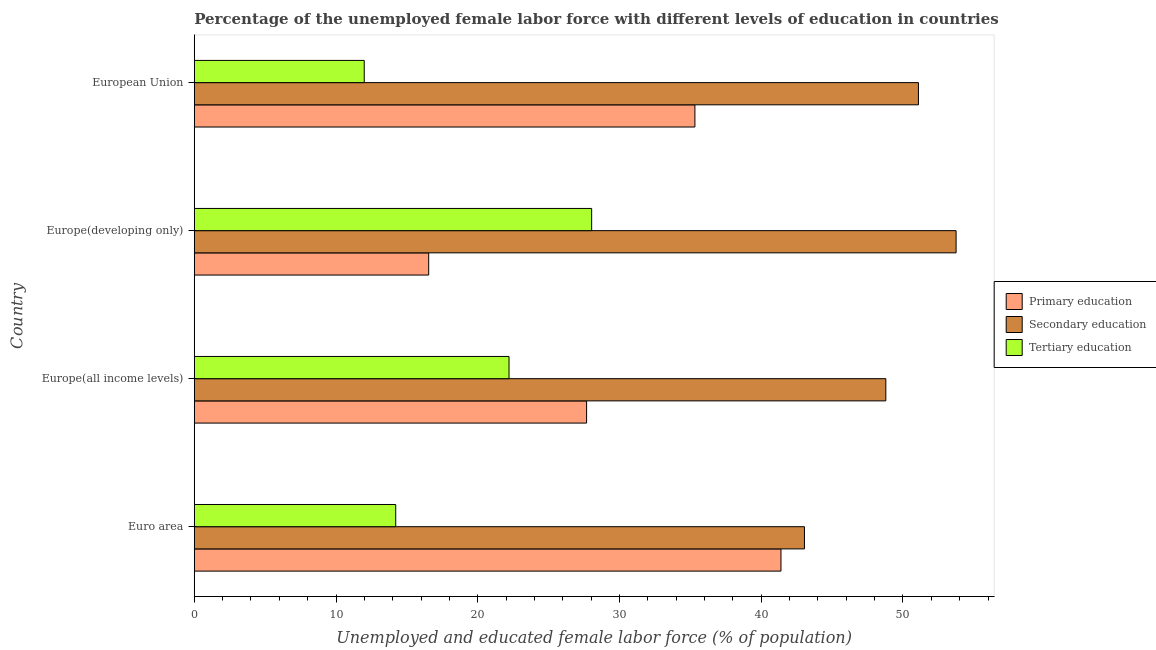How many different coloured bars are there?
Offer a very short reply. 3. Are the number of bars per tick equal to the number of legend labels?
Offer a terse response. Yes. Are the number of bars on each tick of the Y-axis equal?
Ensure brevity in your answer.  Yes. What is the label of the 1st group of bars from the top?
Keep it short and to the point. European Union. In how many cases, is the number of bars for a given country not equal to the number of legend labels?
Make the answer very short. 0. What is the percentage of female labor force who received secondary education in Euro area?
Your answer should be very brief. 43.05. Across all countries, what is the maximum percentage of female labor force who received tertiary education?
Offer a terse response. 28.04. Across all countries, what is the minimum percentage of female labor force who received tertiary education?
Provide a short and direct response. 11.99. In which country was the percentage of female labor force who received primary education maximum?
Your answer should be very brief. Euro area. What is the total percentage of female labor force who received primary education in the graph?
Provide a short and direct response. 120.93. What is the difference between the percentage of female labor force who received primary education in Euro area and that in Europe(all income levels)?
Provide a short and direct response. 13.71. What is the difference between the percentage of female labor force who received primary education in Europe(developing only) and the percentage of female labor force who received tertiary education in Europe(all income levels)?
Ensure brevity in your answer.  -5.67. What is the average percentage of female labor force who received secondary education per country?
Ensure brevity in your answer.  49.17. What is the difference between the percentage of female labor force who received primary education and percentage of female labor force who received tertiary education in European Union?
Provide a short and direct response. 23.33. In how many countries, is the percentage of female labor force who received secondary education greater than 50 %?
Your answer should be compact. 2. What is the ratio of the percentage of female labor force who received primary education in Europe(developing only) to that in European Union?
Make the answer very short. 0.47. Is the percentage of female labor force who received primary education in Europe(all income levels) less than that in Europe(developing only)?
Keep it short and to the point. No. What is the difference between the highest and the second highest percentage of female labor force who received secondary education?
Keep it short and to the point. 2.66. What is the difference between the highest and the lowest percentage of female labor force who received secondary education?
Offer a terse response. 10.7. In how many countries, is the percentage of female labor force who received tertiary education greater than the average percentage of female labor force who received tertiary education taken over all countries?
Your answer should be very brief. 2. What does the 2nd bar from the top in European Union represents?
Provide a succinct answer. Secondary education. What does the 1st bar from the bottom in Europe(developing only) represents?
Ensure brevity in your answer.  Primary education. Is it the case that in every country, the sum of the percentage of female labor force who received primary education and percentage of female labor force who received secondary education is greater than the percentage of female labor force who received tertiary education?
Give a very brief answer. Yes. How many countries are there in the graph?
Provide a succinct answer. 4. Are the values on the major ticks of X-axis written in scientific E-notation?
Provide a short and direct response. No. How many legend labels are there?
Your answer should be very brief. 3. What is the title of the graph?
Provide a short and direct response. Percentage of the unemployed female labor force with different levels of education in countries. What is the label or title of the X-axis?
Keep it short and to the point. Unemployed and educated female labor force (% of population). What is the label or title of the Y-axis?
Your answer should be compact. Country. What is the Unemployed and educated female labor force (% of population) of Primary education in Euro area?
Offer a very short reply. 41.39. What is the Unemployed and educated female labor force (% of population) in Secondary education in Euro area?
Ensure brevity in your answer.  43.05. What is the Unemployed and educated female labor force (% of population) of Tertiary education in Euro area?
Keep it short and to the point. 14.21. What is the Unemployed and educated female labor force (% of population) in Primary education in Europe(all income levels)?
Offer a terse response. 27.68. What is the Unemployed and educated female labor force (% of population) of Secondary education in Europe(all income levels)?
Offer a very short reply. 48.79. What is the Unemployed and educated female labor force (% of population) of Tertiary education in Europe(all income levels)?
Offer a very short reply. 22.21. What is the Unemployed and educated female labor force (% of population) of Primary education in Europe(developing only)?
Ensure brevity in your answer.  16.54. What is the Unemployed and educated female labor force (% of population) in Secondary education in Europe(developing only)?
Make the answer very short. 53.75. What is the Unemployed and educated female labor force (% of population) of Tertiary education in Europe(developing only)?
Provide a short and direct response. 28.04. What is the Unemployed and educated female labor force (% of population) in Primary education in European Union?
Offer a very short reply. 35.32. What is the Unemployed and educated female labor force (% of population) of Secondary education in European Union?
Your answer should be compact. 51.09. What is the Unemployed and educated female labor force (% of population) in Tertiary education in European Union?
Offer a terse response. 11.99. Across all countries, what is the maximum Unemployed and educated female labor force (% of population) in Primary education?
Offer a terse response. 41.39. Across all countries, what is the maximum Unemployed and educated female labor force (% of population) of Secondary education?
Make the answer very short. 53.75. Across all countries, what is the maximum Unemployed and educated female labor force (% of population) in Tertiary education?
Offer a very short reply. 28.04. Across all countries, what is the minimum Unemployed and educated female labor force (% of population) in Primary education?
Keep it short and to the point. 16.54. Across all countries, what is the minimum Unemployed and educated female labor force (% of population) of Secondary education?
Make the answer very short. 43.05. Across all countries, what is the minimum Unemployed and educated female labor force (% of population) in Tertiary education?
Your response must be concise. 11.99. What is the total Unemployed and educated female labor force (% of population) of Primary education in the graph?
Your answer should be compact. 120.93. What is the total Unemployed and educated female labor force (% of population) in Secondary education in the graph?
Your answer should be very brief. 196.68. What is the total Unemployed and educated female labor force (% of population) of Tertiary education in the graph?
Your answer should be very brief. 76.45. What is the difference between the Unemployed and educated female labor force (% of population) in Primary education in Euro area and that in Europe(all income levels)?
Give a very brief answer. 13.71. What is the difference between the Unemployed and educated female labor force (% of population) of Secondary education in Euro area and that in Europe(all income levels)?
Your answer should be very brief. -5.74. What is the difference between the Unemployed and educated female labor force (% of population) in Tertiary education in Euro area and that in Europe(all income levels)?
Keep it short and to the point. -7.99. What is the difference between the Unemployed and educated female labor force (% of population) of Primary education in Euro area and that in Europe(developing only)?
Provide a succinct answer. 24.85. What is the difference between the Unemployed and educated female labor force (% of population) of Secondary education in Euro area and that in Europe(developing only)?
Keep it short and to the point. -10.7. What is the difference between the Unemployed and educated female labor force (% of population) in Tertiary education in Euro area and that in Europe(developing only)?
Keep it short and to the point. -13.82. What is the difference between the Unemployed and educated female labor force (% of population) in Primary education in Euro area and that in European Union?
Provide a short and direct response. 6.07. What is the difference between the Unemployed and educated female labor force (% of population) of Secondary education in Euro area and that in European Union?
Provide a short and direct response. -8.04. What is the difference between the Unemployed and educated female labor force (% of population) of Tertiary education in Euro area and that in European Union?
Ensure brevity in your answer.  2.22. What is the difference between the Unemployed and educated female labor force (% of population) in Primary education in Europe(all income levels) and that in Europe(developing only)?
Provide a short and direct response. 11.14. What is the difference between the Unemployed and educated female labor force (% of population) of Secondary education in Europe(all income levels) and that in Europe(developing only)?
Ensure brevity in your answer.  -4.96. What is the difference between the Unemployed and educated female labor force (% of population) in Tertiary education in Europe(all income levels) and that in Europe(developing only)?
Your response must be concise. -5.83. What is the difference between the Unemployed and educated female labor force (% of population) of Primary education in Europe(all income levels) and that in European Union?
Give a very brief answer. -7.64. What is the difference between the Unemployed and educated female labor force (% of population) in Secondary education in Europe(all income levels) and that in European Union?
Keep it short and to the point. -2.3. What is the difference between the Unemployed and educated female labor force (% of population) of Tertiary education in Europe(all income levels) and that in European Union?
Ensure brevity in your answer.  10.21. What is the difference between the Unemployed and educated female labor force (% of population) in Primary education in Europe(developing only) and that in European Union?
Your response must be concise. -18.78. What is the difference between the Unemployed and educated female labor force (% of population) of Secondary education in Europe(developing only) and that in European Union?
Ensure brevity in your answer.  2.66. What is the difference between the Unemployed and educated female labor force (% of population) in Tertiary education in Europe(developing only) and that in European Union?
Provide a short and direct response. 16.04. What is the difference between the Unemployed and educated female labor force (% of population) in Primary education in Euro area and the Unemployed and educated female labor force (% of population) in Secondary education in Europe(all income levels)?
Your answer should be very brief. -7.4. What is the difference between the Unemployed and educated female labor force (% of population) in Primary education in Euro area and the Unemployed and educated female labor force (% of population) in Tertiary education in Europe(all income levels)?
Ensure brevity in your answer.  19.19. What is the difference between the Unemployed and educated female labor force (% of population) of Secondary education in Euro area and the Unemployed and educated female labor force (% of population) of Tertiary education in Europe(all income levels)?
Give a very brief answer. 20.84. What is the difference between the Unemployed and educated female labor force (% of population) in Primary education in Euro area and the Unemployed and educated female labor force (% of population) in Secondary education in Europe(developing only)?
Ensure brevity in your answer.  -12.35. What is the difference between the Unemployed and educated female labor force (% of population) of Primary education in Euro area and the Unemployed and educated female labor force (% of population) of Tertiary education in Europe(developing only)?
Make the answer very short. 13.36. What is the difference between the Unemployed and educated female labor force (% of population) in Secondary education in Euro area and the Unemployed and educated female labor force (% of population) in Tertiary education in Europe(developing only)?
Give a very brief answer. 15.01. What is the difference between the Unemployed and educated female labor force (% of population) of Primary education in Euro area and the Unemployed and educated female labor force (% of population) of Secondary education in European Union?
Offer a terse response. -9.7. What is the difference between the Unemployed and educated female labor force (% of population) of Primary education in Euro area and the Unemployed and educated female labor force (% of population) of Tertiary education in European Union?
Your answer should be compact. 29.4. What is the difference between the Unemployed and educated female labor force (% of population) of Secondary education in Euro area and the Unemployed and educated female labor force (% of population) of Tertiary education in European Union?
Offer a very short reply. 31.06. What is the difference between the Unemployed and educated female labor force (% of population) in Primary education in Europe(all income levels) and the Unemployed and educated female labor force (% of population) in Secondary education in Europe(developing only)?
Keep it short and to the point. -26.07. What is the difference between the Unemployed and educated female labor force (% of population) of Primary education in Europe(all income levels) and the Unemployed and educated female labor force (% of population) of Tertiary education in Europe(developing only)?
Your answer should be compact. -0.36. What is the difference between the Unemployed and educated female labor force (% of population) of Secondary education in Europe(all income levels) and the Unemployed and educated female labor force (% of population) of Tertiary education in Europe(developing only)?
Your answer should be very brief. 20.76. What is the difference between the Unemployed and educated female labor force (% of population) in Primary education in Europe(all income levels) and the Unemployed and educated female labor force (% of population) in Secondary education in European Union?
Provide a short and direct response. -23.41. What is the difference between the Unemployed and educated female labor force (% of population) in Primary education in Europe(all income levels) and the Unemployed and educated female labor force (% of population) in Tertiary education in European Union?
Ensure brevity in your answer.  15.69. What is the difference between the Unemployed and educated female labor force (% of population) in Secondary education in Europe(all income levels) and the Unemployed and educated female labor force (% of population) in Tertiary education in European Union?
Give a very brief answer. 36.8. What is the difference between the Unemployed and educated female labor force (% of population) of Primary education in Europe(developing only) and the Unemployed and educated female labor force (% of population) of Secondary education in European Union?
Offer a terse response. -34.55. What is the difference between the Unemployed and educated female labor force (% of population) in Primary education in Europe(developing only) and the Unemployed and educated female labor force (% of population) in Tertiary education in European Union?
Ensure brevity in your answer.  4.55. What is the difference between the Unemployed and educated female labor force (% of population) in Secondary education in Europe(developing only) and the Unemployed and educated female labor force (% of population) in Tertiary education in European Union?
Your response must be concise. 41.76. What is the average Unemployed and educated female labor force (% of population) in Primary education per country?
Offer a very short reply. 30.23. What is the average Unemployed and educated female labor force (% of population) in Secondary education per country?
Your answer should be compact. 49.17. What is the average Unemployed and educated female labor force (% of population) in Tertiary education per country?
Provide a short and direct response. 19.11. What is the difference between the Unemployed and educated female labor force (% of population) in Primary education and Unemployed and educated female labor force (% of population) in Secondary education in Euro area?
Keep it short and to the point. -1.66. What is the difference between the Unemployed and educated female labor force (% of population) in Primary education and Unemployed and educated female labor force (% of population) in Tertiary education in Euro area?
Keep it short and to the point. 27.18. What is the difference between the Unemployed and educated female labor force (% of population) in Secondary education and Unemployed and educated female labor force (% of population) in Tertiary education in Euro area?
Your answer should be very brief. 28.84. What is the difference between the Unemployed and educated female labor force (% of population) of Primary education and Unemployed and educated female labor force (% of population) of Secondary education in Europe(all income levels)?
Keep it short and to the point. -21.11. What is the difference between the Unemployed and educated female labor force (% of population) of Primary education and Unemployed and educated female labor force (% of population) of Tertiary education in Europe(all income levels)?
Ensure brevity in your answer.  5.47. What is the difference between the Unemployed and educated female labor force (% of population) of Secondary education and Unemployed and educated female labor force (% of population) of Tertiary education in Europe(all income levels)?
Keep it short and to the point. 26.59. What is the difference between the Unemployed and educated female labor force (% of population) in Primary education and Unemployed and educated female labor force (% of population) in Secondary education in Europe(developing only)?
Make the answer very short. -37.21. What is the difference between the Unemployed and educated female labor force (% of population) in Primary education and Unemployed and educated female labor force (% of population) in Tertiary education in Europe(developing only)?
Your response must be concise. -11.5. What is the difference between the Unemployed and educated female labor force (% of population) of Secondary education and Unemployed and educated female labor force (% of population) of Tertiary education in Europe(developing only)?
Ensure brevity in your answer.  25.71. What is the difference between the Unemployed and educated female labor force (% of population) of Primary education and Unemployed and educated female labor force (% of population) of Secondary education in European Union?
Keep it short and to the point. -15.77. What is the difference between the Unemployed and educated female labor force (% of population) in Primary education and Unemployed and educated female labor force (% of population) in Tertiary education in European Union?
Your response must be concise. 23.33. What is the difference between the Unemployed and educated female labor force (% of population) of Secondary education and Unemployed and educated female labor force (% of population) of Tertiary education in European Union?
Make the answer very short. 39.1. What is the ratio of the Unemployed and educated female labor force (% of population) in Primary education in Euro area to that in Europe(all income levels)?
Offer a very short reply. 1.5. What is the ratio of the Unemployed and educated female labor force (% of population) of Secondary education in Euro area to that in Europe(all income levels)?
Offer a terse response. 0.88. What is the ratio of the Unemployed and educated female labor force (% of population) of Tertiary education in Euro area to that in Europe(all income levels)?
Your response must be concise. 0.64. What is the ratio of the Unemployed and educated female labor force (% of population) in Primary education in Euro area to that in Europe(developing only)?
Keep it short and to the point. 2.5. What is the ratio of the Unemployed and educated female labor force (% of population) in Secondary education in Euro area to that in Europe(developing only)?
Ensure brevity in your answer.  0.8. What is the ratio of the Unemployed and educated female labor force (% of population) of Tertiary education in Euro area to that in Europe(developing only)?
Offer a terse response. 0.51. What is the ratio of the Unemployed and educated female labor force (% of population) in Primary education in Euro area to that in European Union?
Provide a short and direct response. 1.17. What is the ratio of the Unemployed and educated female labor force (% of population) in Secondary education in Euro area to that in European Union?
Your response must be concise. 0.84. What is the ratio of the Unemployed and educated female labor force (% of population) in Tertiary education in Euro area to that in European Union?
Your answer should be very brief. 1.19. What is the ratio of the Unemployed and educated female labor force (% of population) of Primary education in Europe(all income levels) to that in Europe(developing only)?
Offer a terse response. 1.67. What is the ratio of the Unemployed and educated female labor force (% of population) of Secondary education in Europe(all income levels) to that in Europe(developing only)?
Keep it short and to the point. 0.91. What is the ratio of the Unemployed and educated female labor force (% of population) in Tertiary education in Europe(all income levels) to that in Europe(developing only)?
Offer a very short reply. 0.79. What is the ratio of the Unemployed and educated female labor force (% of population) in Primary education in Europe(all income levels) to that in European Union?
Your answer should be very brief. 0.78. What is the ratio of the Unemployed and educated female labor force (% of population) in Secondary education in Europe(all income levels) to that in European Union?
Your response must be concise. 0.95. What is the ratio of the Unemployed and educated female labor force (% of population) in Tertiary education in Europe(all income levels) to that in European Union?
Give a very brief answer. 1.85. What is the ratio of the Unemployed and educated female labor force (% of population) of Primary education in Europe(developing only) to that in European Union?
Your answer should be very brief. 0.47. What is the ratio of the Unemployed and educated female labor force (% of population) of Secondary education in Europe(developing only) to that in European Union?
Offer a terse response. 1.05. What is the ratio of the Unemployed and educated female labor force (% of population) of Tertiary education in Europe(developing only) to that in European Union?
Ensure brevity in your answer.  2.34. What is the difference between the highest and the second highest Unemployed and educated female labor force (% of population) of Primary education?
Offer a terse response. 6.07. What is the difference between the highest and the second highest Unemployed and educated female labor force (% of population) in Secondary education?
Keep it short and to the point. 2.66. What is the difference between the highest and the second highest Unemployed and educated female labor force (% of population) of Tertiary education?
Your answer should be very brief. 5.83. What is the difference between the highest and the lowest Unemployed and educated female labor force (% of population) of Primary education?
Provide a succinct answer. 24.85. What is the difference between the highest and the lowest Unemployed and educated female labor force (% of population) in Secondary education?
Provide a short and direct response. 10.7. What is the difference between the highest and the lowest Unemployed and educated female labor force (% of population) in Tertiary education?
Your answer should be very brief. 16.04. 